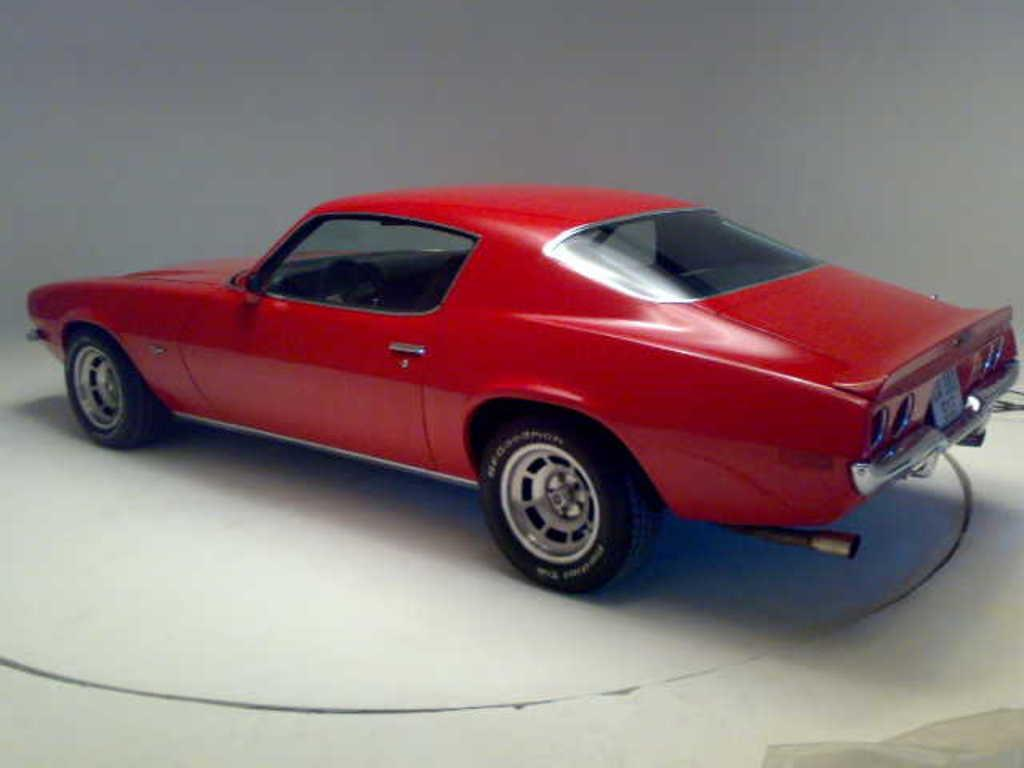What is the main subject in the middle of the image? There is a car in the middle of the image. What is the surface on which the car is placed? There is a floor at the bottom of the image. What can be seen behind the car in the image? There is a wall in the background of the image. What date is circled on the calendar in the image? There is no calendar present in the image. What type of sky is visible in the image? The image does not show the sky; it only shows a car, a floor, and a wall. 